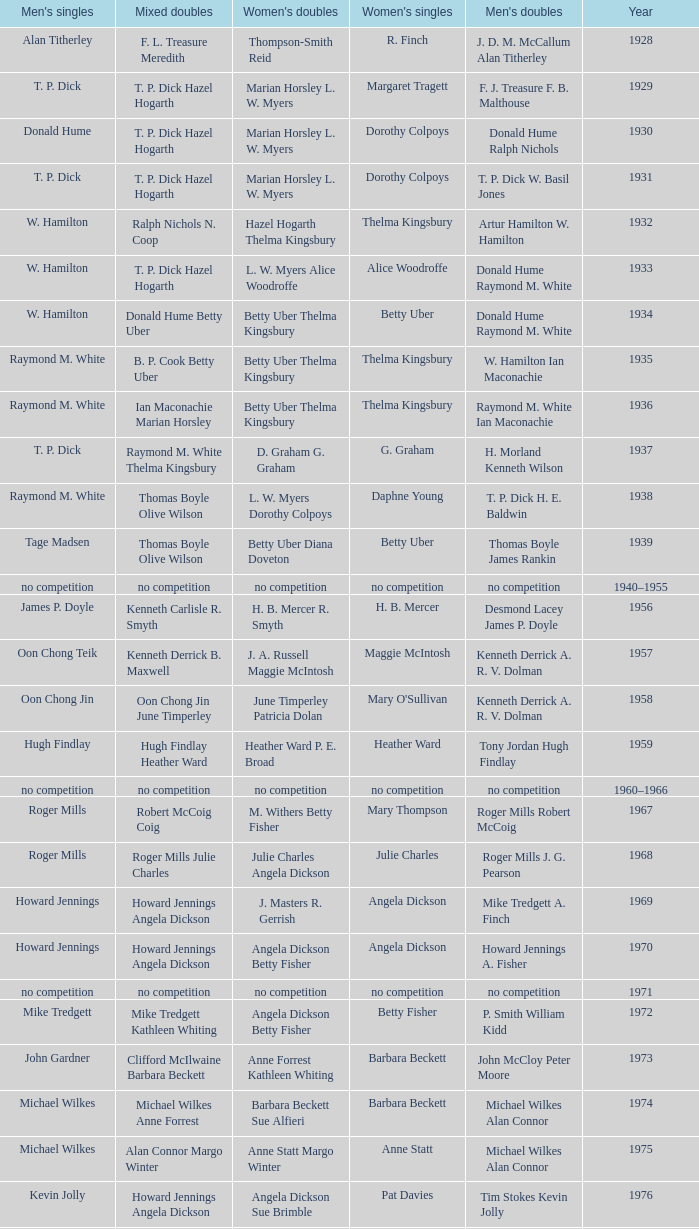Who won the Women's doubles in the year that Jesper Knudsen Nettie Nielsen won the Mixed doubles? Karen Beckman Sara Halsall. 